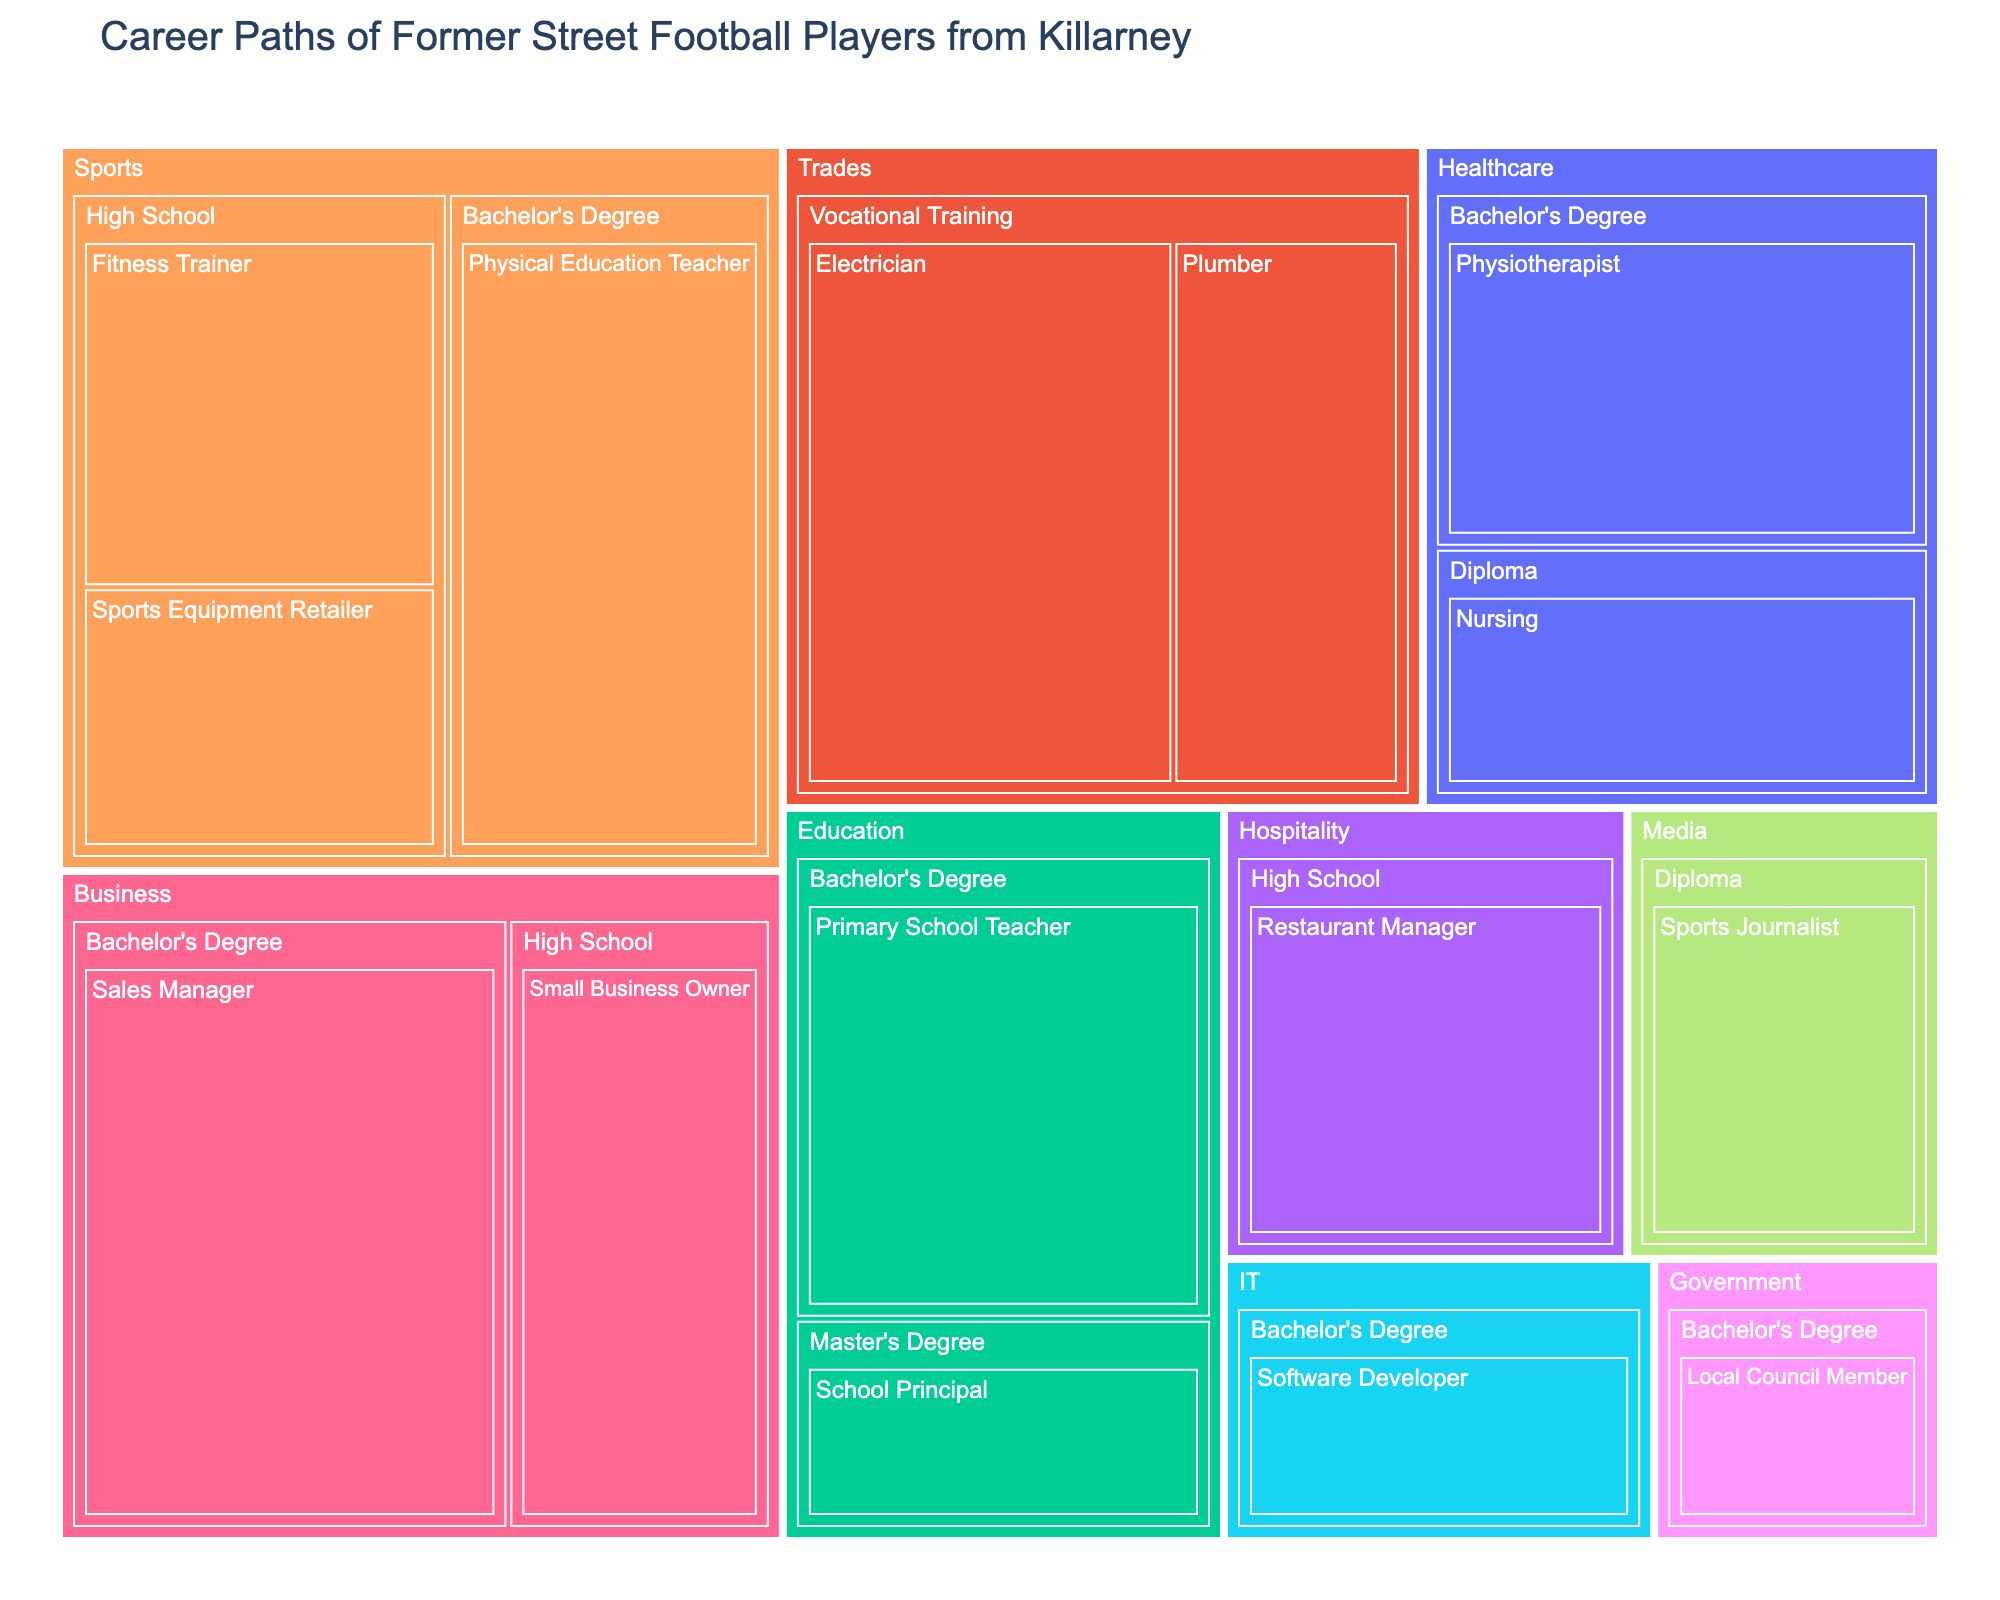How many industries are represented in the treemap? The treemap divides career paths into different industries. By counting the distinct sections in the graph, you can determine the number of industries.
Answer: 7 Which career path within the "Sports" industry has the highest number of former players? Examine the sections within the "Sports" industry and compare their values. The career path with the highest value is the one with the largest section.
Answer: Physical Education Teacher What is the combined number of former players in the "Trades" industry? Sum the values of the career paths within the "Trades" industry. This involves adding the number of Electricians and Plumbers.
Answer: 21 Which education level has the largest representation in the "Business" industry? Identify and compare the different education levels within the "Business" industry. The education level with the largest value is the most represented.
Answer: Bachelor's Degree How does the number of former players who became physiotherapists compare to those who became software developers? Locate the sections for Physiotherapists and Software Developers and compare their numbers to see which is greater.
Answer: Physiotherapists (10) have more players than Software Developers (6) Which industry has the smallest number of former players in a single career path, and what is that career path? Look for the smallest section in the treemap and identify the industry and career path it represents.
Answer: Government, Local Council Member What is the difference in the number of former players in the "Healthcare" industry between those who pursued Bachelor's degrees and those who pursued Diplomas? Subtract the number of players with Diplomas from those with Bachelor's degrees within the "Healthcare" industry (10 - 7).
Answer: 3 How many former players pursued careers in the "Media" industry? Identify the section representing the "Media" industry and note its value. This value indicates the number of players in that industry.
Answer: 7 Compare the representation of "Fitness Trainers" in the "Sports" industry to "Restaurant Managers" in the "Hospitality" industry. Locate both career paths in their respective industries and compare their values to identify which has more former players.
Answer: Restaurant Managers (9) have more players than Fitness Trainers (8) Which career paths in the "Education" industry require a Bachelor's degree, and how many former players chose each path? Look at the paths in the "Education" industry and identify those requiring a Bachelor's degree, including their respective number of players.
Answer: Primary School Teacher (11) 